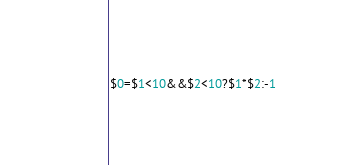<code> <loc_0><loc_0><loc_500><loc_500><_Awk_>$0=$1<10&&$2<10?$1*$2:-1</code> 